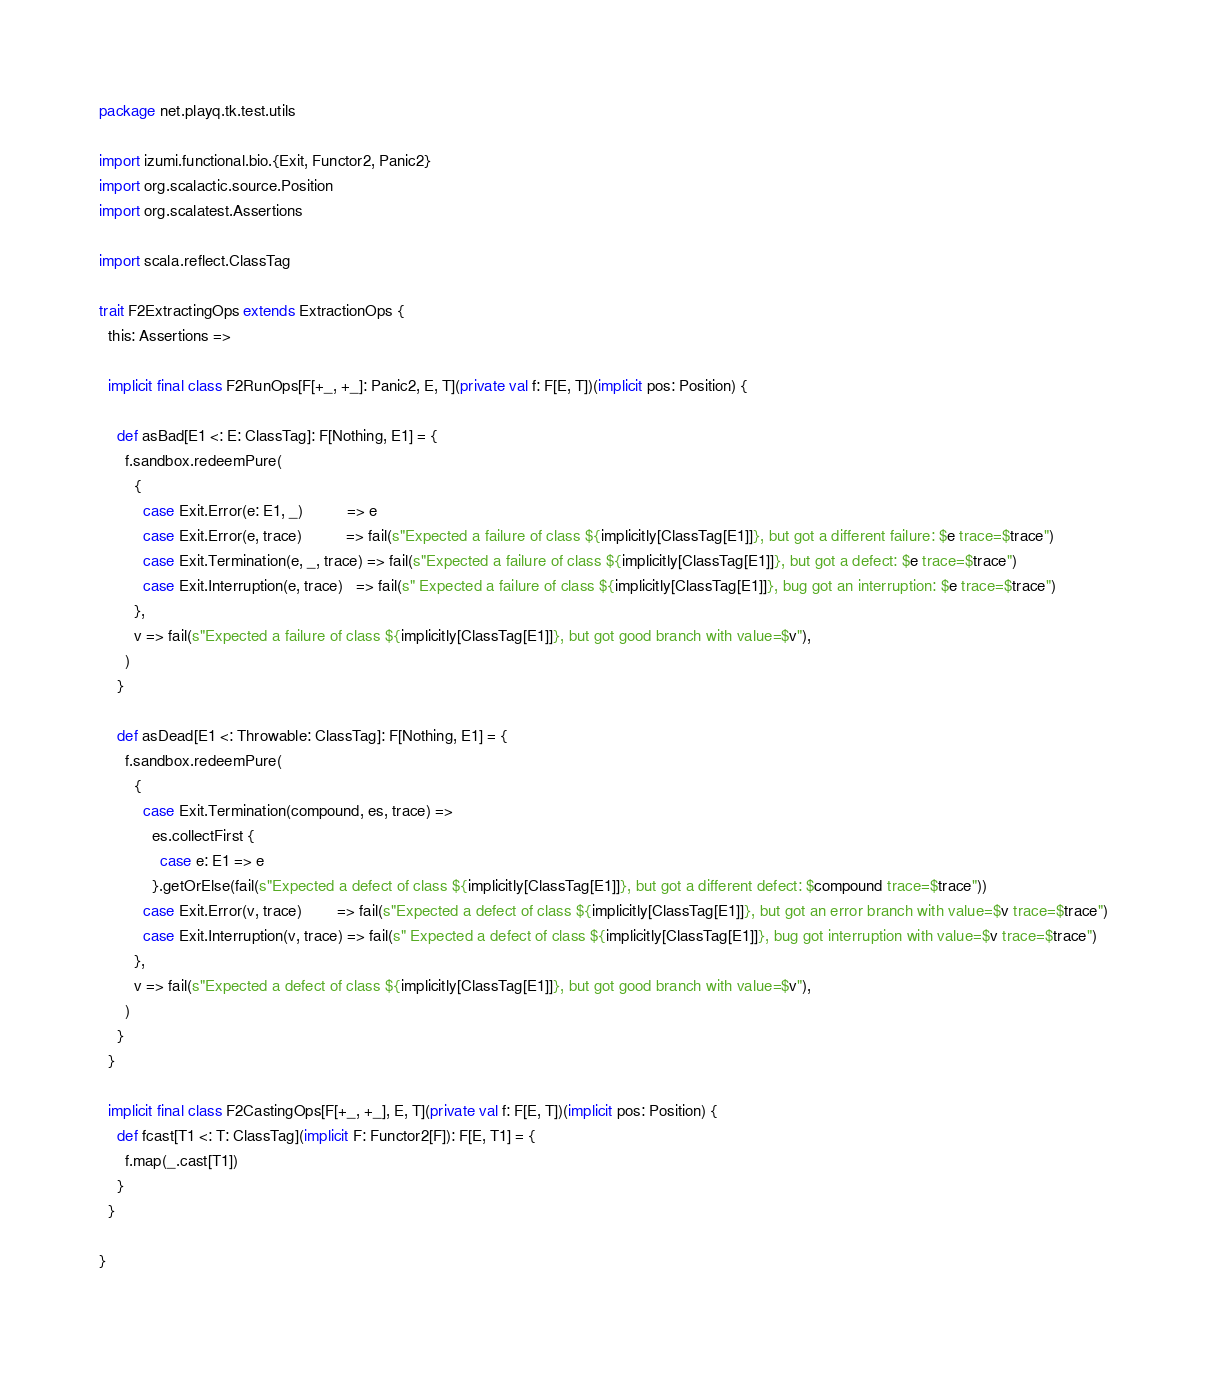<code> <loc_0><loc_0><loc_500><loc_500><_Scala_>package net.playq.tk.test.utils

import izumi.functional.bio.{Exit, Functor2, Panic2}
import org.scalactic.source.Position
import org.scalatest.Assertions

import scala.reflect.ClassTag

trait F2ExtractingOps extends ExtractionOps {
  this: Assertions =>

  implicit final class F2RunOps[F[+_, +_]: Panic2, E, T](private val f: F[E, T])(implicit pos: Position) {

    def asBad[E1 <: E: ClassTag]: F[Nothing, E1] = {
      f.sandbox.redeemPure(
        {
          case Exit.Error(e: E1, _)          => e
          case Exit.Error(e, trace)          => fail(s"Expected a failure of class ${implicitly[ClassTag[E1]]}, but got a different failure: $e trace=$trace")
          case Exit.Termination(e, _, trace) => fail(s"Expected a failure of class ${implicitly[ClassTag[E1]]}, but got a defect: $e trace=$trace")
          case Exit.Interruption(e, trace)   => fail(s" Expected a failure of class ${implicitly[ClassTag[E1]]}, bug got an interruption: $e trace=$trace")
        },
        v => fail(s"Expected a failure of class ${implicitly[ClassTag[E1]]}, but got good branch with value=$v"),
      )
    }

    def asDead[E1 <: Throwable: ClassTag]: F[Nothing, E1] = {
      f.sandbox.redeemPure(
        {
          case Exit.Termination(compound, es, trace) =>
            es.collectFirst {
              case e: E1 => e
            }.getOrElse(fail(s"Expected a defect of class ${implicitly[ClassTag[E1]]}, but got a different defect: $compound trace=$trace"))
          case Exit.Error(v, trace)        => fail(s"Expected a defect of class ${implicitly[ClassTag[E1]]}, but got an error branch with value=$v trace=$trace")
          case Exit.Interruption(v, trace) => fail(s" Expected a defect of class ${implicitly[ClassTag[E1]]}, bug got interruption with value=$v trace=$trace")
        },
        v => fail(s"Expected a defect of class ${implicitly[ClassTag[E1]]}, but got good branch with value=$v"),
      )
    }
  }

  implicit final class F2CastingOps[F[+_, +_], E, T](private val f: F[E, T])(implicit pos: Position) {
    def fcast[T1 <: T: ClassTag](implicit F: Functor2[F]): F[E, T1] = {
      f.map(_.cast[T1])
    }
  }

}
</code> 